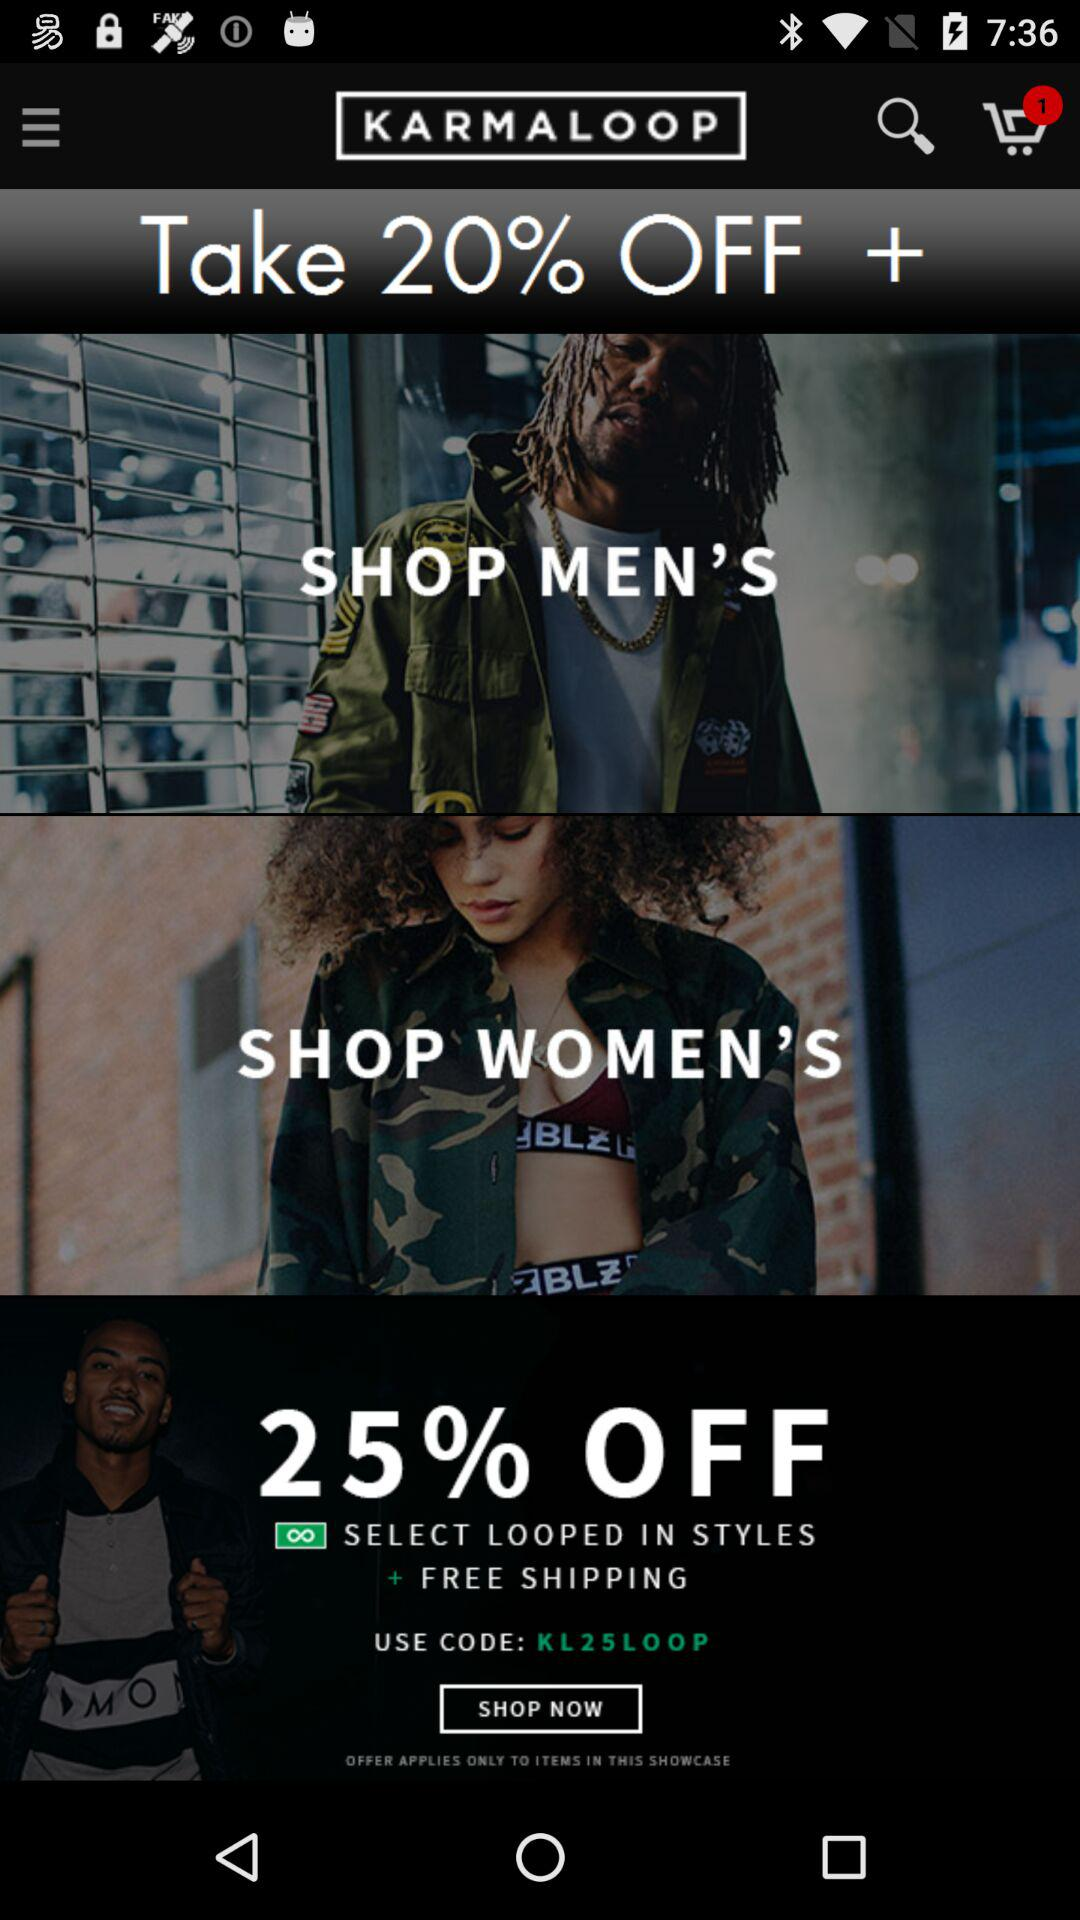How many items have a discount?
Answer the question using a single word or phrase. 2 